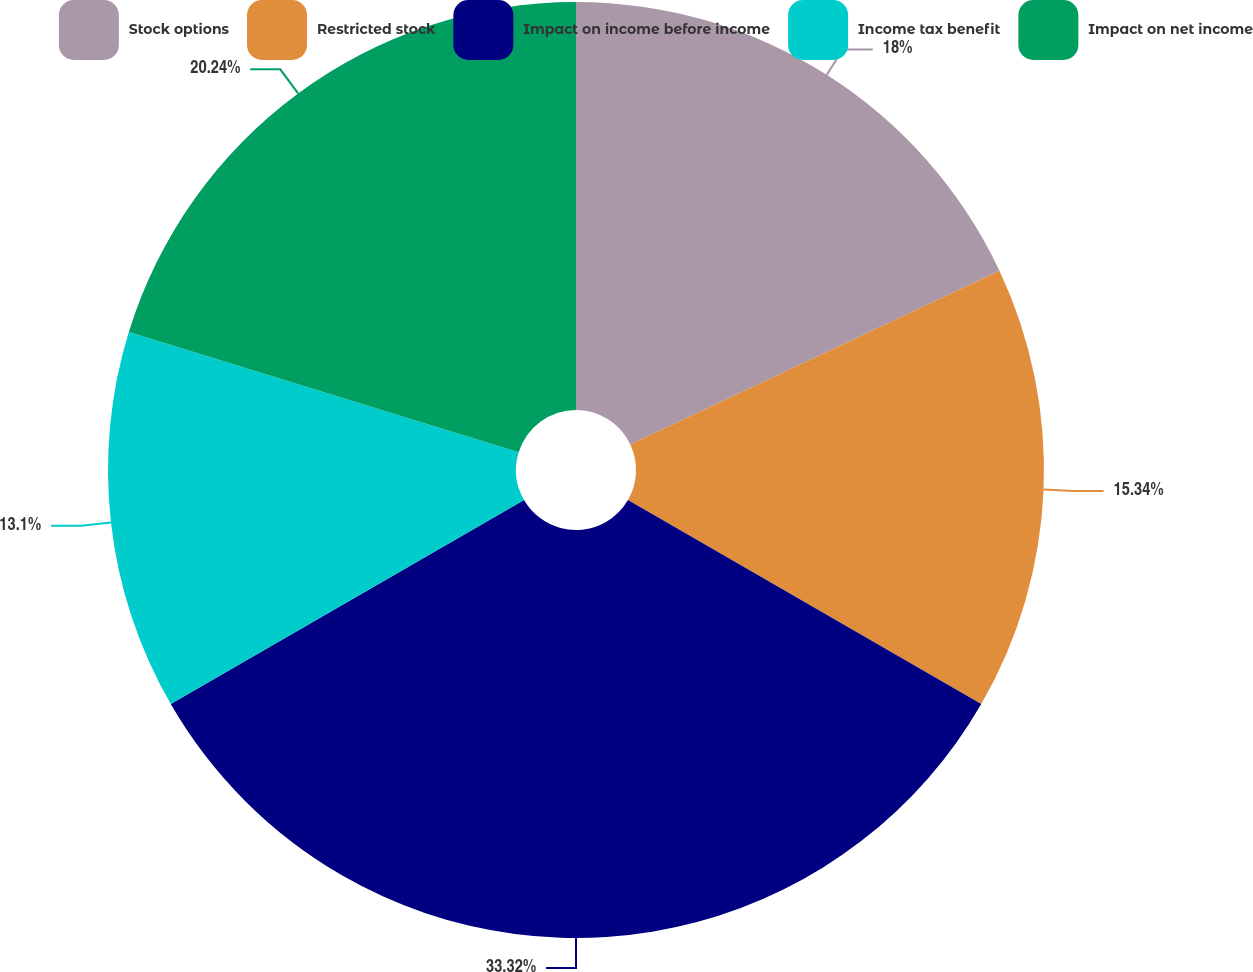<chart> <loc_0><loc_0><loc_500><loc_500><pie_chart><fcel>Stock options<fcel>Restricted stock<fcel>Impact on income before income<fcel>Income tax benefit<fcel>Impact on net income<nl><fcel>18.0%<fcel>15.34%<fcel>33.33%<fcel>13.1%<fcel>20.24%<nl></chart> 